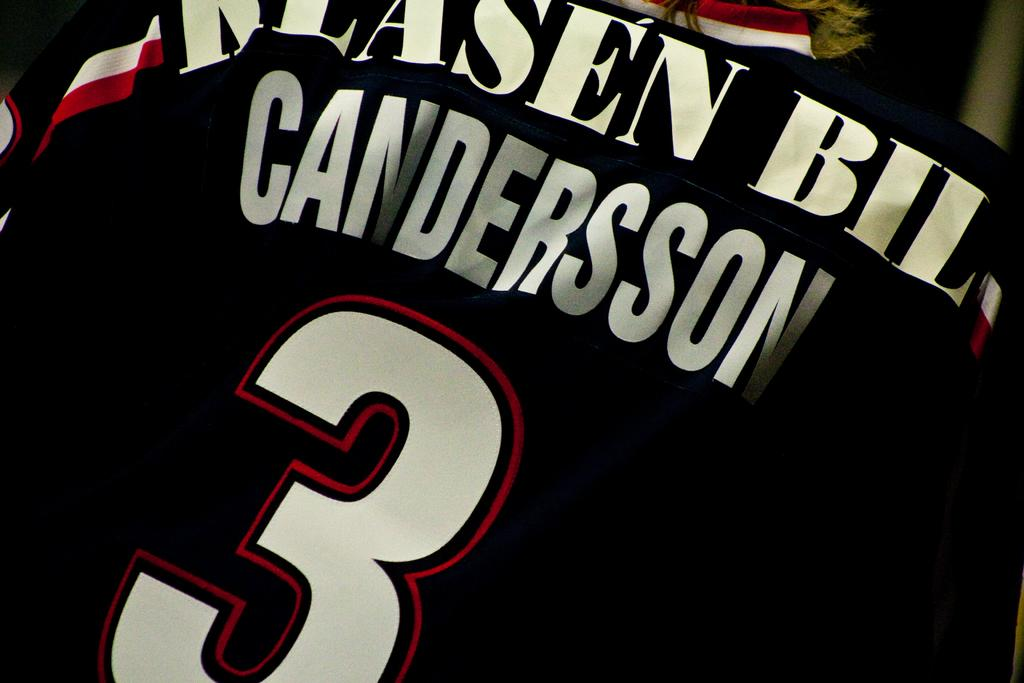<image>
Create a compact narrative representing the image presented. The back of a black jersey of Klasen Bill Candersson showing the number 3. 